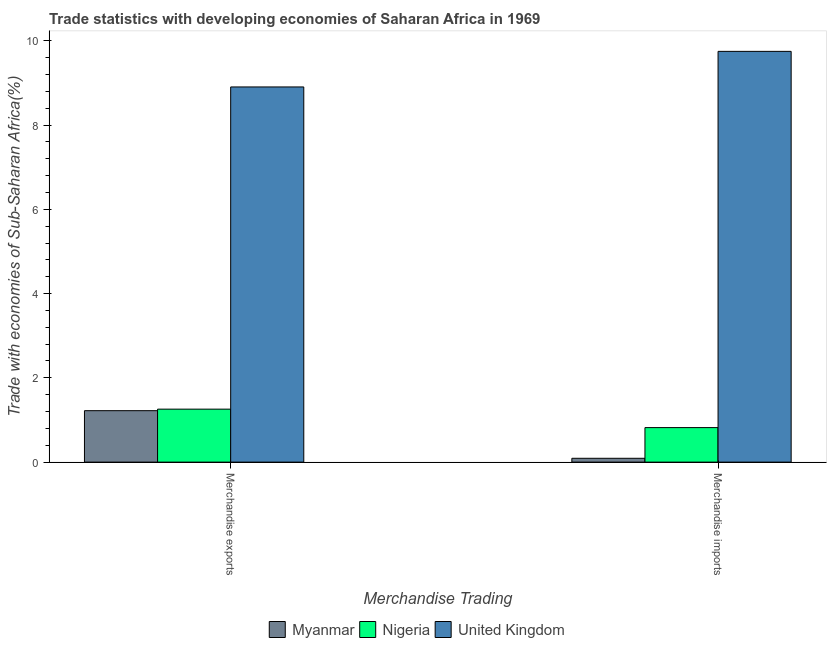How many groups of bars are there?
Provide a short and direct response. 2. What is the merchandise exports in Nigeria?
Ensure brevity in your answer.  1.26. Across all countries, what is the maximum merchandise imports?
Your answer should be very brief. 9.75. Across all countries, what is the minimum merchandise exports?
Keep it short and to the point. 1.22. In which country was the merchandise imports minimum?
Your answer should be very brief. Myanmar. What is the total merchandise imports in the graph?
Provide a succinct answer. 10.66. What is the difference between the merchandise imports in Myanmar and that in United Kingdom?
Offer a terse response. -9.66. What is the difference between the merchandise exports in Nigeria and the merchandise imports in United Kingdom?
Provide a succinct answer. -8.49. What is the average merchandise exports per country?
Keep it short and to the point. 3.79. What is the difference between the merchandise imports and merchandise exports in Myanmar?
Provide a short and direct response. -1.13. What is the ratio of the merchandise exports in Nigeria to that in Myanmar?
Your answer should be very brief. 1.03. What does the 1st bar from the left in Merchandise imports represents?
Offer a terse response. Myanmar. What does the 1st bar from the right in Merchandise imports represents?
Ensure brevity in your answer.  United Kingdom. How many bars are there?
Your response must be concise. 6. How many countries are there in the graph?
Your answer should be compact. 3. Are the values on the major ticks of Y-axis written in scientific E-notation?
Make the answer very short. No. Does the graph contain any zero values?
Make the answer very short. No. What is the title of the graph?
Provide a short and direct response. Trade statistics with developing economies of Saharan Africa in 1969. What is the label or title of the X-axis?
Offer a terse response. Merchandise Trading. What is the label or title of the Y-axis?
Keep it short and to the point. Trade with economies of Sub-Saharan Africa(%). What is the Trade with economies of Sub-Saharan Africa(%) of Myanmar in Merchandise exports?
Make the answer very short. 1.22. What is the Trade with economies of Sub-Saharan Africa(%) of Nigeria in Merchandise exports?
Provide a short and direct response. 1.26. What is the Trade with economies of Sub-Saharan Africa(%) of United Kingdom in Merchandise exports?
Provide a short and direct response. 8.9. What is the Trade with economies of Sub-Saharan Africa(%) of Myanmar in Merchandise imports?
Provide a short and direct response. 0.09. What is the Trade with economies of Sub-Saharan Africa(%) of Nigeria in Merchandise imports?
Offer a very short reply. 0.82. What is the Trade with economies of Sub-Saharan Africa(%) of United Kingdom in Merchandise imports?
Your answer should be compact. 9.75. Across all Merchandise Trading, what is the maximum Trade with economies of Sub-Saharan Africa(%) in Myanmar?
Keep it short and to the point. 1.22. Across all Merchandise Trading, what is the maximum Trade with economies of Sub-Saharan Africa(%) in Nigeria?
Provide a succinct answer. 1.26. Across all Merchandise Trading, what is the maximum Trade with economies of Sub-Saharan Africa(%) of United Kingdom?
Provide a short and direct response. 9.75. Across all Merchandise Trading, what is the minimum Trade with economies of Sub-Saharan Africa(%) in Myanmar?
Provide a short and direct response. 0.09. Across all Merchandise Trading, what is the minimum Trade with economies of Sub-Saharan Africa(%) in Nigeria?
Your answer should be compact. 0.82. Across all Merchandise Trading, what is the minimum Trade with economies of Sub-Saharan Africa(%) of United Kingdom?
Give a very brief answer. 8.9. What is the total Trade with economies of Sub-Saharan Africa(%) of Myanmar in the graph?
Provide a short and direct response. 1.31. What is the total Trade with economies of Sub-Saharan Africa(%) of Nigeria in the graph?
Ensure brevity in your answer.  2.08. What is the total Trade with economies of Sub-Saharan Africa(%) in United Kingdom in the graph?
Offer a very short reply. 18.65. What is the difference between the Trade with economies of Sub-Saharan Africa(%) in Myanmar in Merchandise exports and that in Merchandise imports?
Ensure brevity in your answer.  1.13. What is the difference between the Trade with economies of Sub-Saharan Africa(%) of Nigeria in Merchandise exports and that in Merchandise imports?
Your answer should be compact. 0.44. What is the difference between the Trade with economies of Sub-Saharan Africa(%) of United Kingdom in Merchandise exports and that in Merchandise imports?
Your response must be concise. -0.84. What is the difference between the Trade with economies of Sub-Saharan Africa(%) in Myanmar in Merchandise exports and the Trade with economies of Sub-Saharan Africa(%) in Nigeria in Merchandise imports?
Your response must be concise. 0.4. What is the difference between the Trade with economies of Sub-Saharan Africa(%) in Myanmar in Merchandise exports and the Trade with economies of Sub-Saharan Africa(%) in United Kingdom in Merchandise imports?
Give a very brief answer. -8.53. What is the difference between the Trade with economies of Sub-Saharan Africa(%) in Nigeria in Merchandise exports and the Trade with economies of Sub-Saharan Africa(%) in United Kingdom in Merchandise imports?
Make the answer very short. -8.49. What is the average Trade with economies of Sub-Saharan Africa(%) in Myanmar per Merchandise Trading?
Offer a terse response. 0.66. What is the average Trade with economies of Sub-Saharan Africa(%) in Nigeria per Merchandise Trading?
Provide a succinct answer. 1.04. What is the average Trade with economies of Sub-Saharan Africa(%) in United Kingdom per Merchandise Trading?
Ensure brevity in your answer.  9.33. What is the difference between the Trade with economies of Sub-Saharan Africa(%) in Myanmar and Trade with economies of Sub-Saharan Africa(%) in Nigeria in Merchandise exports?
Your response must be concise. -0.04. What is the difference between the Trade with economies of Sub-Saharan Africa(%) in Myanmar and Trade with economies of Sub-Saharan Africa(%) in United Kingdom in Merchandise exports?
Your response must be concise. -7.68. What is the difference between the Trade with economies of Sub-Saharan Africa(%) in Nigeria and Trade with economies of Sub-Saharan Africa(%) in United Kingdom in Merchandise exports?
Keep it short and to the point. -7.65. What is the difference between the Trade with economies of Sub-Saharan Africa(%) of Myanmar and Trade with economies of Sub-Saharan Africa(%) of Nigeria in Merchandise imports?
Provide a succinct answer. -0.73. What is the difference between the Trade with economies of Sub-Saharan Africa(%) in Myanmar and Trade with economies of Sub-Saharan Africa(%) in United Kingdom in Merchandise imports?
Offer a terse response. -9.66. What is the difference between the Trade with economies of Sub-Saharan Africa(%) of Nigeria and Trade with economies of Sub-Saharan Africa(%) of United Kingdom in Merchandise imports?
Make the answer very short. -8.93. What is the ratio of the Trade with economies of Sub-Saharan Africa(%) of Myanmar in Merchandise exports to that in Merchandise imports?
Make the answer very short. 13.42. What is the ratio of the Trade with economies of Sub-Saharan Africa(%) in Nigeria in Merchandise exports to that in Merchandise imports?
Your answer should be very brief. 1.53. What is the ratio of the Trade with economies of Sub-Saharan Africa(%) of United Kingdom in Merchandise exports to that in Merchandise imports?
Keep it short and to the point. 0.91. What is the difference between the highest and the second highest Trade with economies of Sub-Saharan Africa(%) in Myanmar?
Give a very brief answer. 1.13. What is the difference between the highest and the second highest Trade with economies of Sub-Saharan Africa(%) of Nigeria?
Your answer should be compact. 0.44. What is the difference between the highest and the second highest Trade with economies of Sub-Saharan Africa(%) in United Kingdom?
Your response must be concise. 0.84. What is the difference between the highest and the lowest Trade with economies of Sub-Saharan Africa(%) of Myanmar?
Your answer should be compact. 1.13. What is the difference between the highest and the lowest Trade with economies of Sub-Saharan Africa(%) in Nigeria?
Offer a terse response. 0.44. What is the difference between the highest and the lowest Trade with economies of Sub-Saharan Africa(%) of United Kingdom?
Keep it short and to the point. 0.84. 